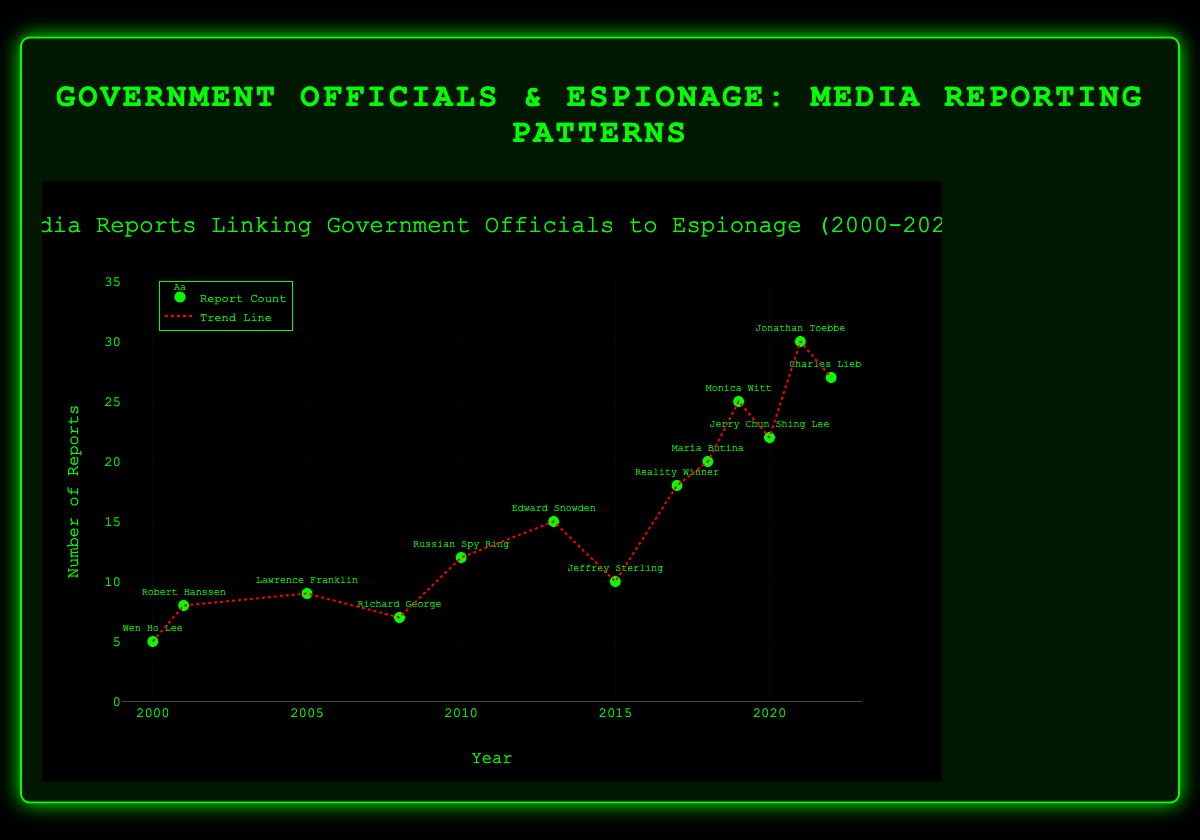What's the title of the figure? The title of the figure is displayed prominently at the top of the chart.
Answer: Media Reports Linking Government Officials to Espionage (2000-2022) How many data points are shown in the plot? Each year from 2000 to 2022 has a data point representing the number of reports. Count each point corresponding to the provided years.
Answer: 13 Which year had the highest number of espionage-related media reports? Look for the data point that has the highest vertical position on the y-axis.
Answer: 2021 What is the notable case associated with the year 2013? Refer to the text labels next to the data points to find the specific annotated case for the year 2013.
Answer: Edward Snowden On which year did the trend line begin to indicate a sharper increase in the number of reports? Observe the trend line's slope; it becomes steeper around 2017-2018.
Answer: Around 2017-2018 Compare the number of reports in 2000 and 2020. How many more reports were there in 2020 compared to 2000? Locate the y-values for 2000 and 2020, and calculate the difference (22 - 5).
Answer: 17 more reports What is the average number of reports between the years 2015 and 2021 inclusive? Sum the report counts from 2015 to 2021 and divide by the total number of years (10 + 18 + 20 + 25 + 22 + 30) / 7.
Answer: 20.71 Which year has fewer reports: 2008 or 2015? Compare the y-values for the years 2008 and 2015, and identify the smaller value.
Answer: 2008 What is the general trend of espionage-related media reports from 2000 to 2022? Observe the overall direction of the trend line moving from left to right, which indicates an increase over the years.
Answer: Increasing In which year did the number of espionage-related reports first exceed 15? Review the graph and locate the first year where a data point is above the y-value of 15.
Answer: 2017 